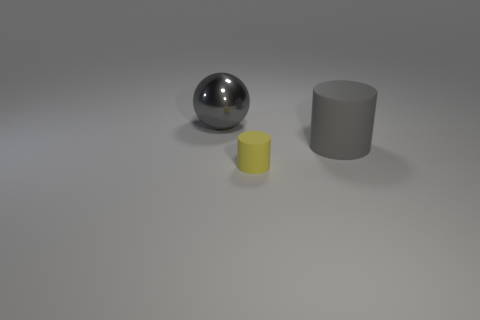What is the size of the rubber thing that is the same color as the metal ball?
Ensure brevity in your answer.  Large. Are there more gray rubber cylinders that are on the left side of the big gray cylinder than gray things?
Give a very brief answer. No. There is a yellow matte thing; is it the same shape as the large gray thing right of the small cylinder?
Your response must be concise. Yes. What number of cylinders are the same size as the metallic object?
Your response must be concise. 1. What number of big gray matte things are in front of the large object that is in front of the gray object left of the gray rubber cylinder?
Give a very brief answer. 0. Are there an equal number of gray metal spheres that are in front of the tiny matte cylinder and large balls behind the big sphere?
Provide a short and direct response. Yes. How many small yellow things are the same shape as the large gray rubber thing?
Make the answer very short. 1. Is there a small thing made of the same material as the gray cylinder?
Keep it short and to the point. Yes. What is the shape of the matte thing that is the same color as the metal sphere?
Your response must be concise. Cylinder. What number of brown blocks are there?
Give a very brief answer. 0. 